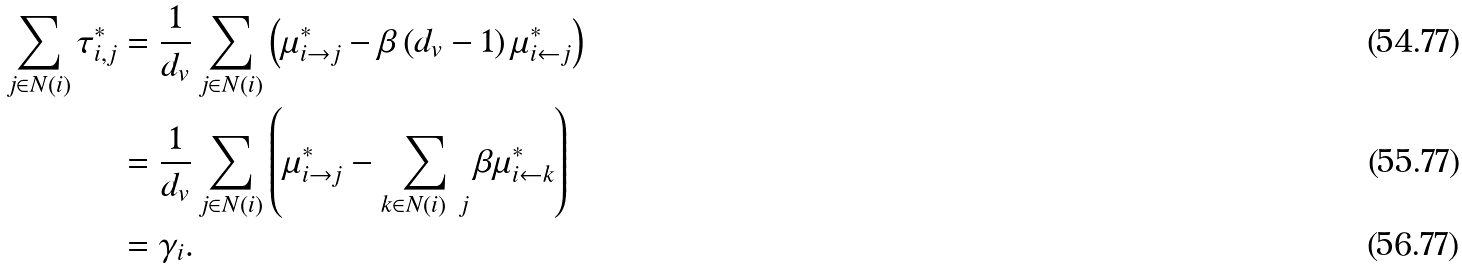<formula> <loc_0><loc_0><loc_500><loc_500>\sum _ { j \in N ( i ) } \tau _ { i , j } ^ { * } & = \frac { 1 } { d _ { v } } \sum _ { j \in N ( i ) } \left ( \mu _ { i \rightarrow j } ^ { * } - \beta \left ( d _ { v } - 1 \right ) \mu _ { i \leftarrow j } ^ { * } \right ) \\ & = \frac { 1 } { d _ { v } } \sum _ { j \in N ( i ) } \left ( \mu _ { i \rightarrow j } ^ { * } - \sum _ { k \in N ( i ) \ j } \beta \mu _ { i \leftarrow k } ^ { * } \right ) \\ & = \gamma _ { i } .</formula> 